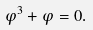<formula> <loc_0><loc_0><loc_500><loc_500>\varphi ^ { 3 } + \varphi = 0 .</formula> 